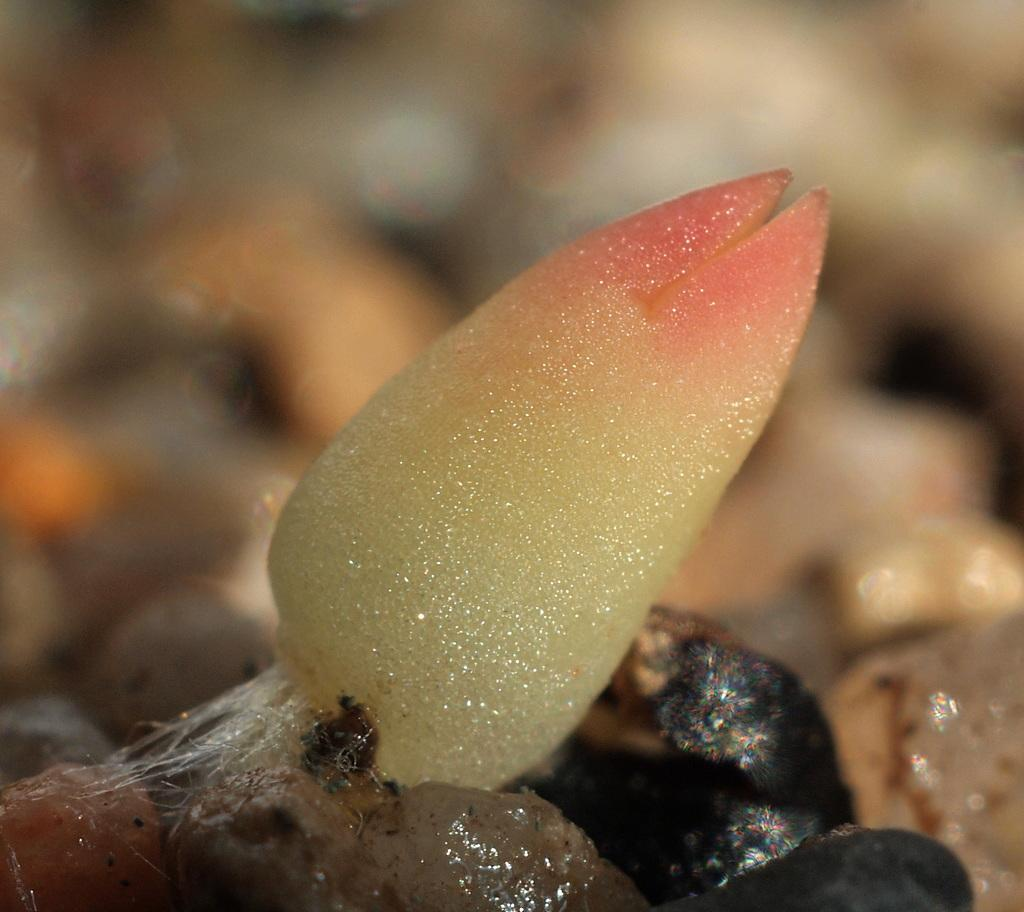What type of object is in the foreground of the image? There is a marine object in the foreground of the image. Can you describe the background of the image? The background of the image is blurry. What type of request is the girl making while wearing a mitten in the image? There is no girl or mitten present in the image, so this question cannot be answered. 